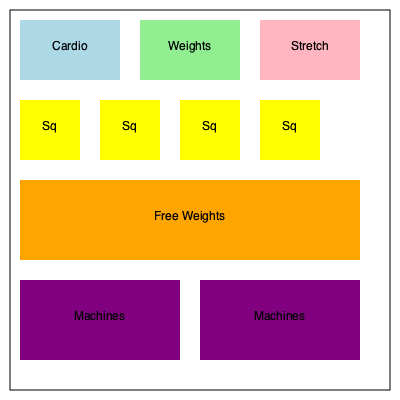Based on the gym floor plan provided, which area is most efficiently utilized in terms of space allocation and potential for simultaneous use by multiple clients? Consider the layout's impact on traffic flow and equipment accessibility. To determine the most efficiently utilized area, we need to analyze each section of the gym floor plan:

1. Cardio Area (top left):
   - Pros: Separated from other areas, reducing congestion.
   - Cons: Limited space, may accommodate fewer machines.

2. Weights Area (top center):
   - Pros: Central location, easy access.
   - Cons: Potentially crowded, limited space.

3. Stretch Area (top right):
   - Pros: Dedicated space for stretching.
   - Cons: Might be underutilized compared to other areas.

4. Squat Racks (second row):
   - Pros: Evenly spaced, allowing multiple users.
   - Cons: May create bottlenecks during peak hours.

5. Free Weights Area (center):
   - Pros: Large space, can accommodate many users simultaneously.
   - Cons: Potential for crowding if not well-organized.

6. Machine Areas (bottom):
   - Pros: Divided into two sections, reducing congestion.
   - Cons: May limit the variety of machines available.

Considering these factors, the Free Weights Area appears to be the most efficiently utilized for the following reasons:

1. Largest contiguous space, allowing for flexible arrangement of equipment.
2. Central location provides easy access from other areas.
3. Can accommodate multiple users simultaneously, maximizing usage.
4. Allows for a variety of exercises and equipment setups.
5. Acts as a buffer zone between other areas, improving overall traffic flow.

The Free Weights Area's size and location make it the most versatile and efficiently utilized space in this gym layout.
Answer: Free Weights Area 